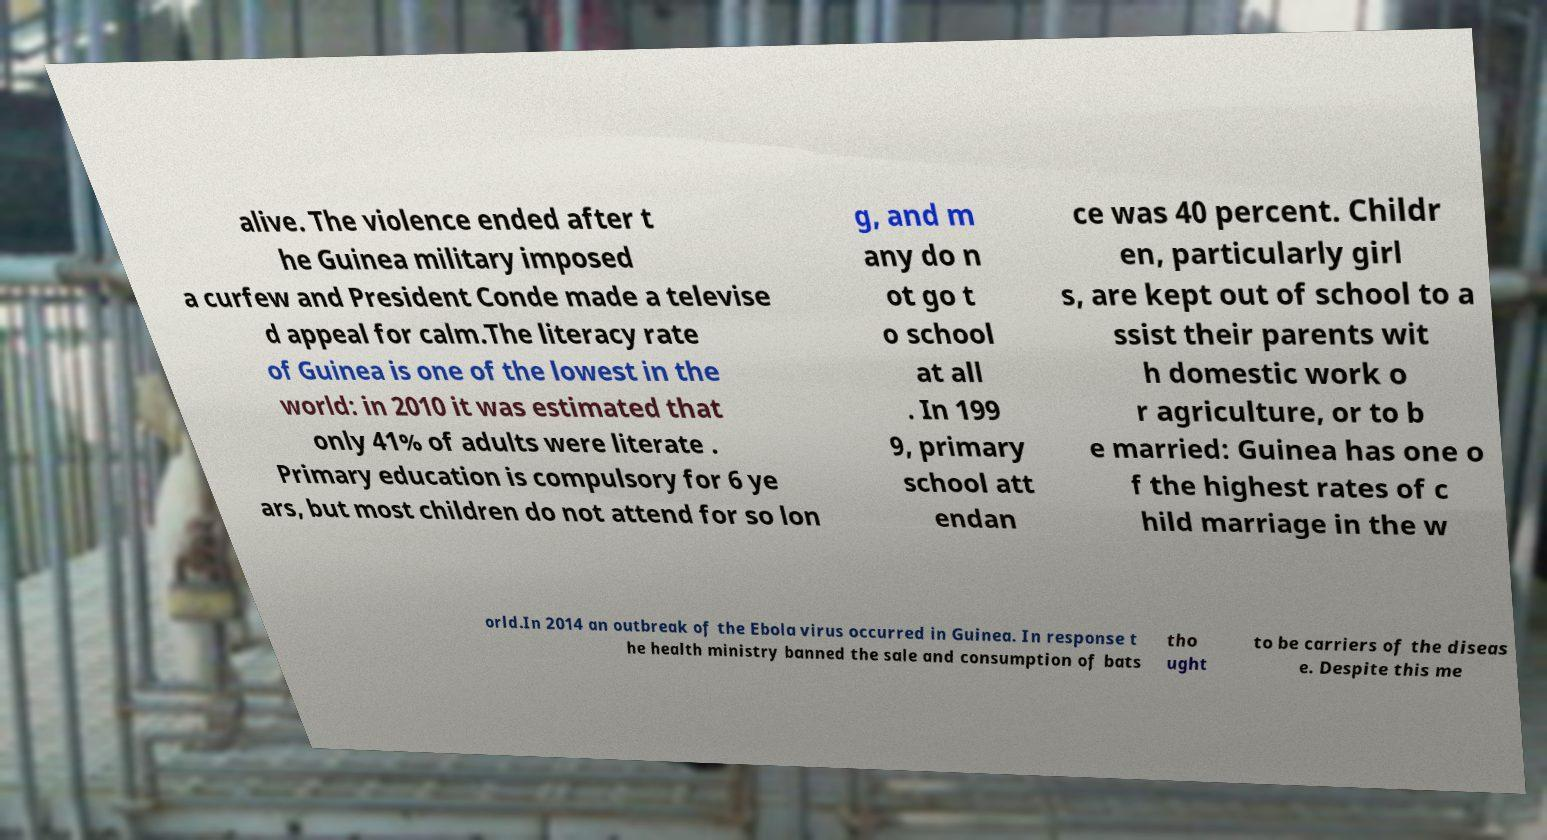I need the written content from this picture converted into text. Can you do that? alive. The violence ended after t he Guinea military imposed a curfew and President Conde made a televise d appeal for calm.The literacy rate of Guinea is one of the lowest in the world: in 2010 it was estimated that only 41% of adults were literate . Primary education is compulsory for 6 ye ars, but most children do not attend for so lon g, and m any do n ot go t o school at all . In 199 9, primary school att endan ce was 40 percent. Childr en, particularly girl s, are kept out of school to a ssist their parents wit h domestic work o r agriculture, or to b e married: Guinea has one o f the highest rates of c hild marriage in the w orld.In 2014 an outbreak of the Ebola virus occurred in Guinea. In response t he health ministry banned the sale and consumption of bats tho ught to be carriers of the diseas e. Despite this me 